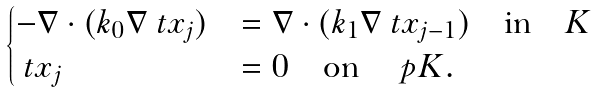<formula> <loc_0><loc_0><loc_500><loc_500>\begin{cases} - \nabla \cdot ( k _ { 0 } \nabla \ t x _ { j } ) & = \nabla \cdot ( k _ { 1 } \nabla \ t x _ { j - 1 } ) \quad \text {in} \quad K \\ \ t x _ { j } & = 0 \quad \text {on} \quad \ p K . \end{cases}</formula> 